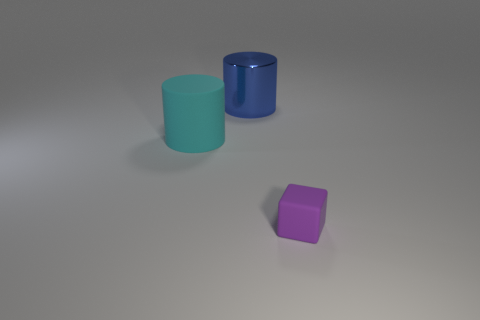Are there any other things that have the same material as the big blue cylinder?
Offer a very short reply. No. Are there more cyan rubber objects right of the purple rubber block than large green rubber things?
Your response must be concise. No. There is a cylinder on the right side of the rubber object on the left side of the rubber cube; what color is it?
Make the answer very short. Blue. How many big rubber objects are there?
Give a very brief answer. 1. What number of things are both to the right of the cyan matte thing and to the left of the purple block?
Keep it short and to the point. 1. Is there any other thing that has the same shape as the big blue object?
Your answer should be very brief. Yes. There is a metal thing; does it have the same color as the matte object in front of the big cyan rubber object?
Offer a very short reply. No. The matte object in front of the large matte thing has what shape?
Your answer should be compact. Cube. What number of other objects are the same material as the cyan cylinder?
Offer a terse response. 1. What material is the big cyan thing?
Offer a very short reply. Rubber. 